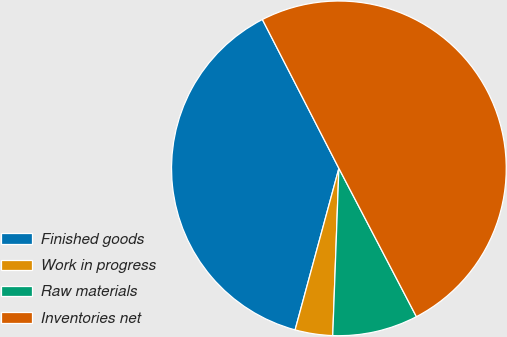<chart> <loc_0><loc_0><loc_500><loc_500><pie_chart><fcel>Finished goods<fcel>Work in progress<fcel>Raw materials<fcel>Inventories net<nl><fcel>38.23%<fcel>3.63%<fcel>8.25%<fcel>49.89%<nl></chart> 